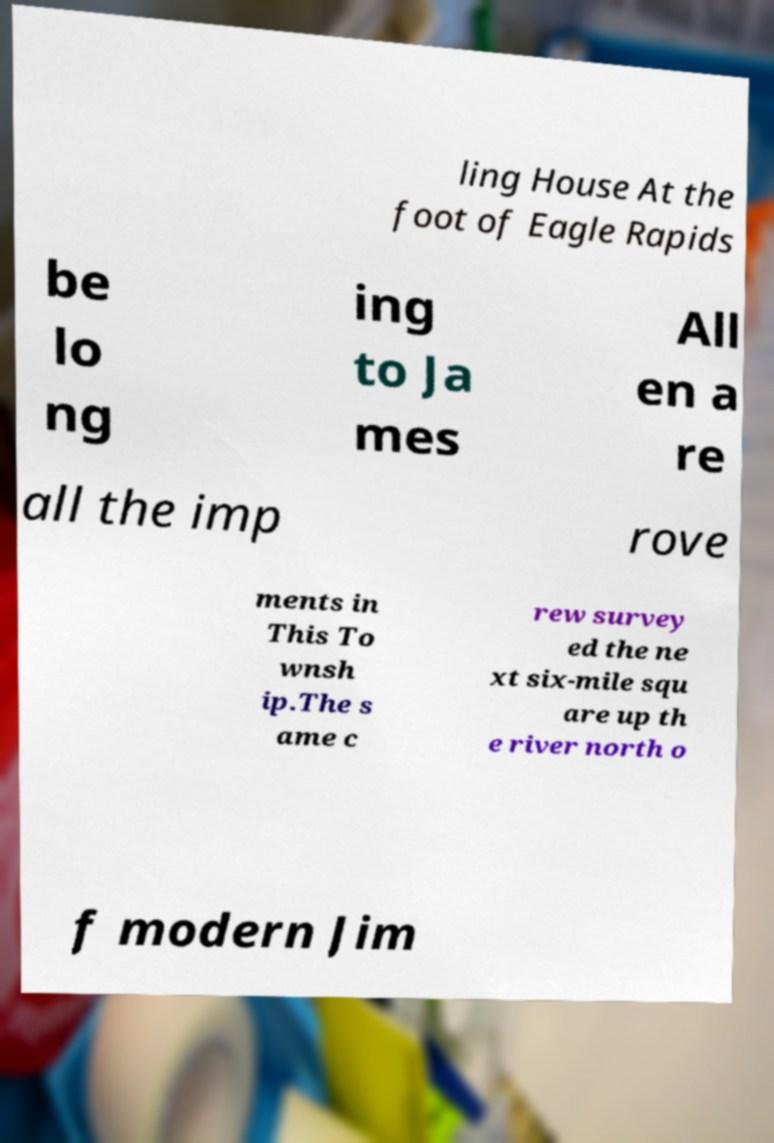Please identify and transcribe the text found in this image. ling House At the foot of Eagle Rapids be lo ng ing to Ja mes All en a re all the imp rove ments in This To wnsh ip.The s ame c rew survey ed the ne xt six-mile squ are up th e river north o f modern Jim 